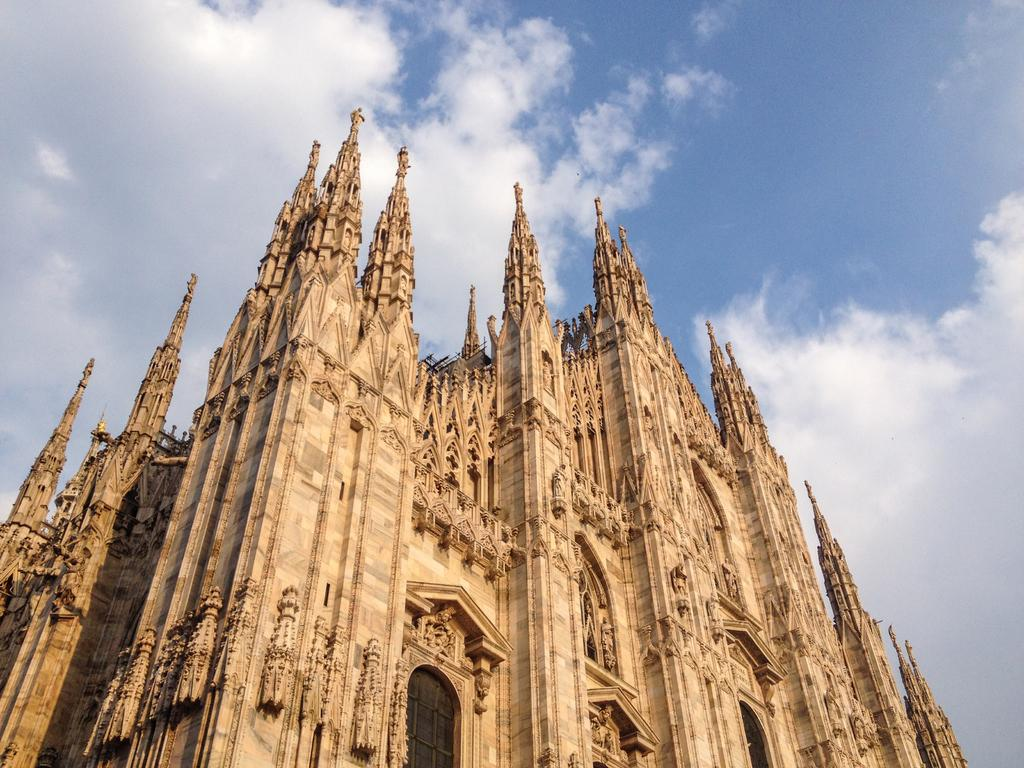What type of building is in the image? There is a church in the image. What feature can be seen on the church? The church has windows. What is visible in the background of the image? The sky is visible in the background of the image. What can be observed in the sky in the image? There are clouds in the sky. Where can the town's soda can be found in the image? There is no town, soda, or can present in the image. 